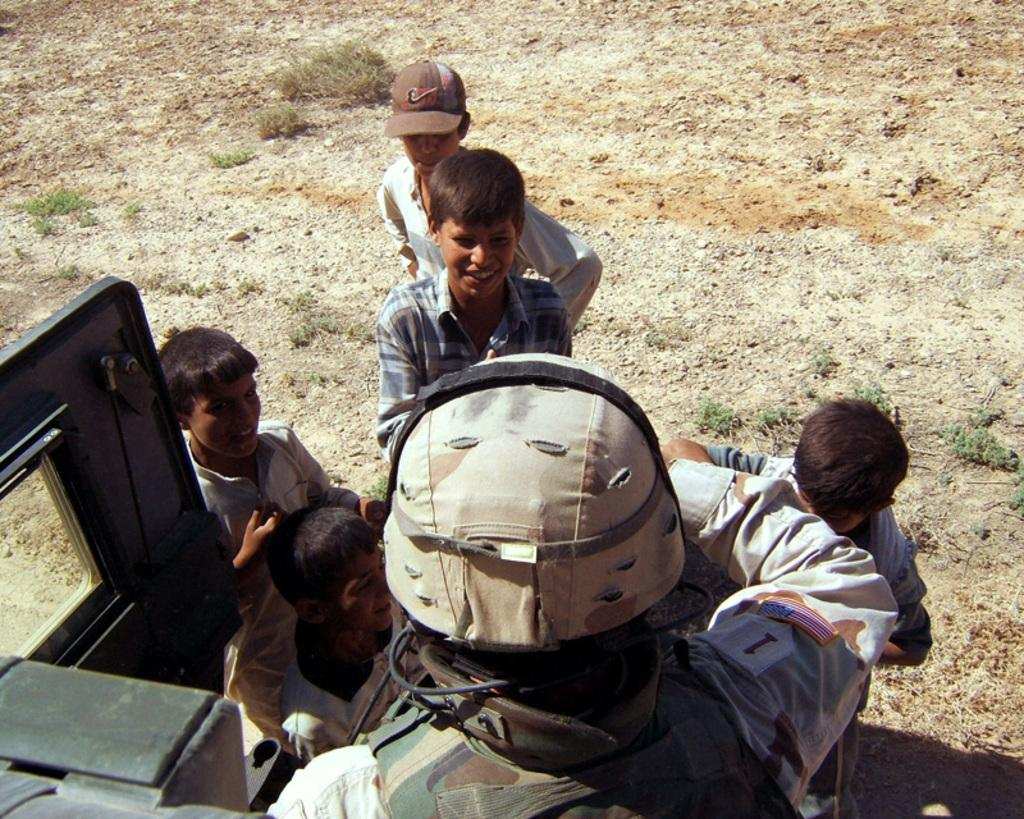Who or what can be seen in the image? There are people in the image. What is the surface beneath the people's feet? The ground is visible in the image. What type of vegetation is present in the image? There is grass in the image. Can you describe the object on the right side of the image? Unfortunately, the provided facts do not specify the nature of the object on the right side of the image. What type of wax can be seen melting on the train tracks in the image? There is no mention of wax or trains in the provided facts, and therefore no such activity can be observed in the image. 